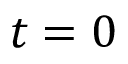Convert formula to latex. <formula><loc_0><loc_0><loc_500><loc_500>t = 0</formula> 